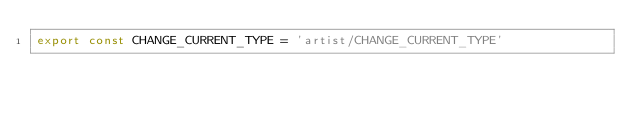<code> <loc_0><loc_0><loc_500><loc_500><_JavaScript_>export const CHANGE_CURRENT_TYPE = 'artist/CHANGE_CURRENT_TYPE'</code> 